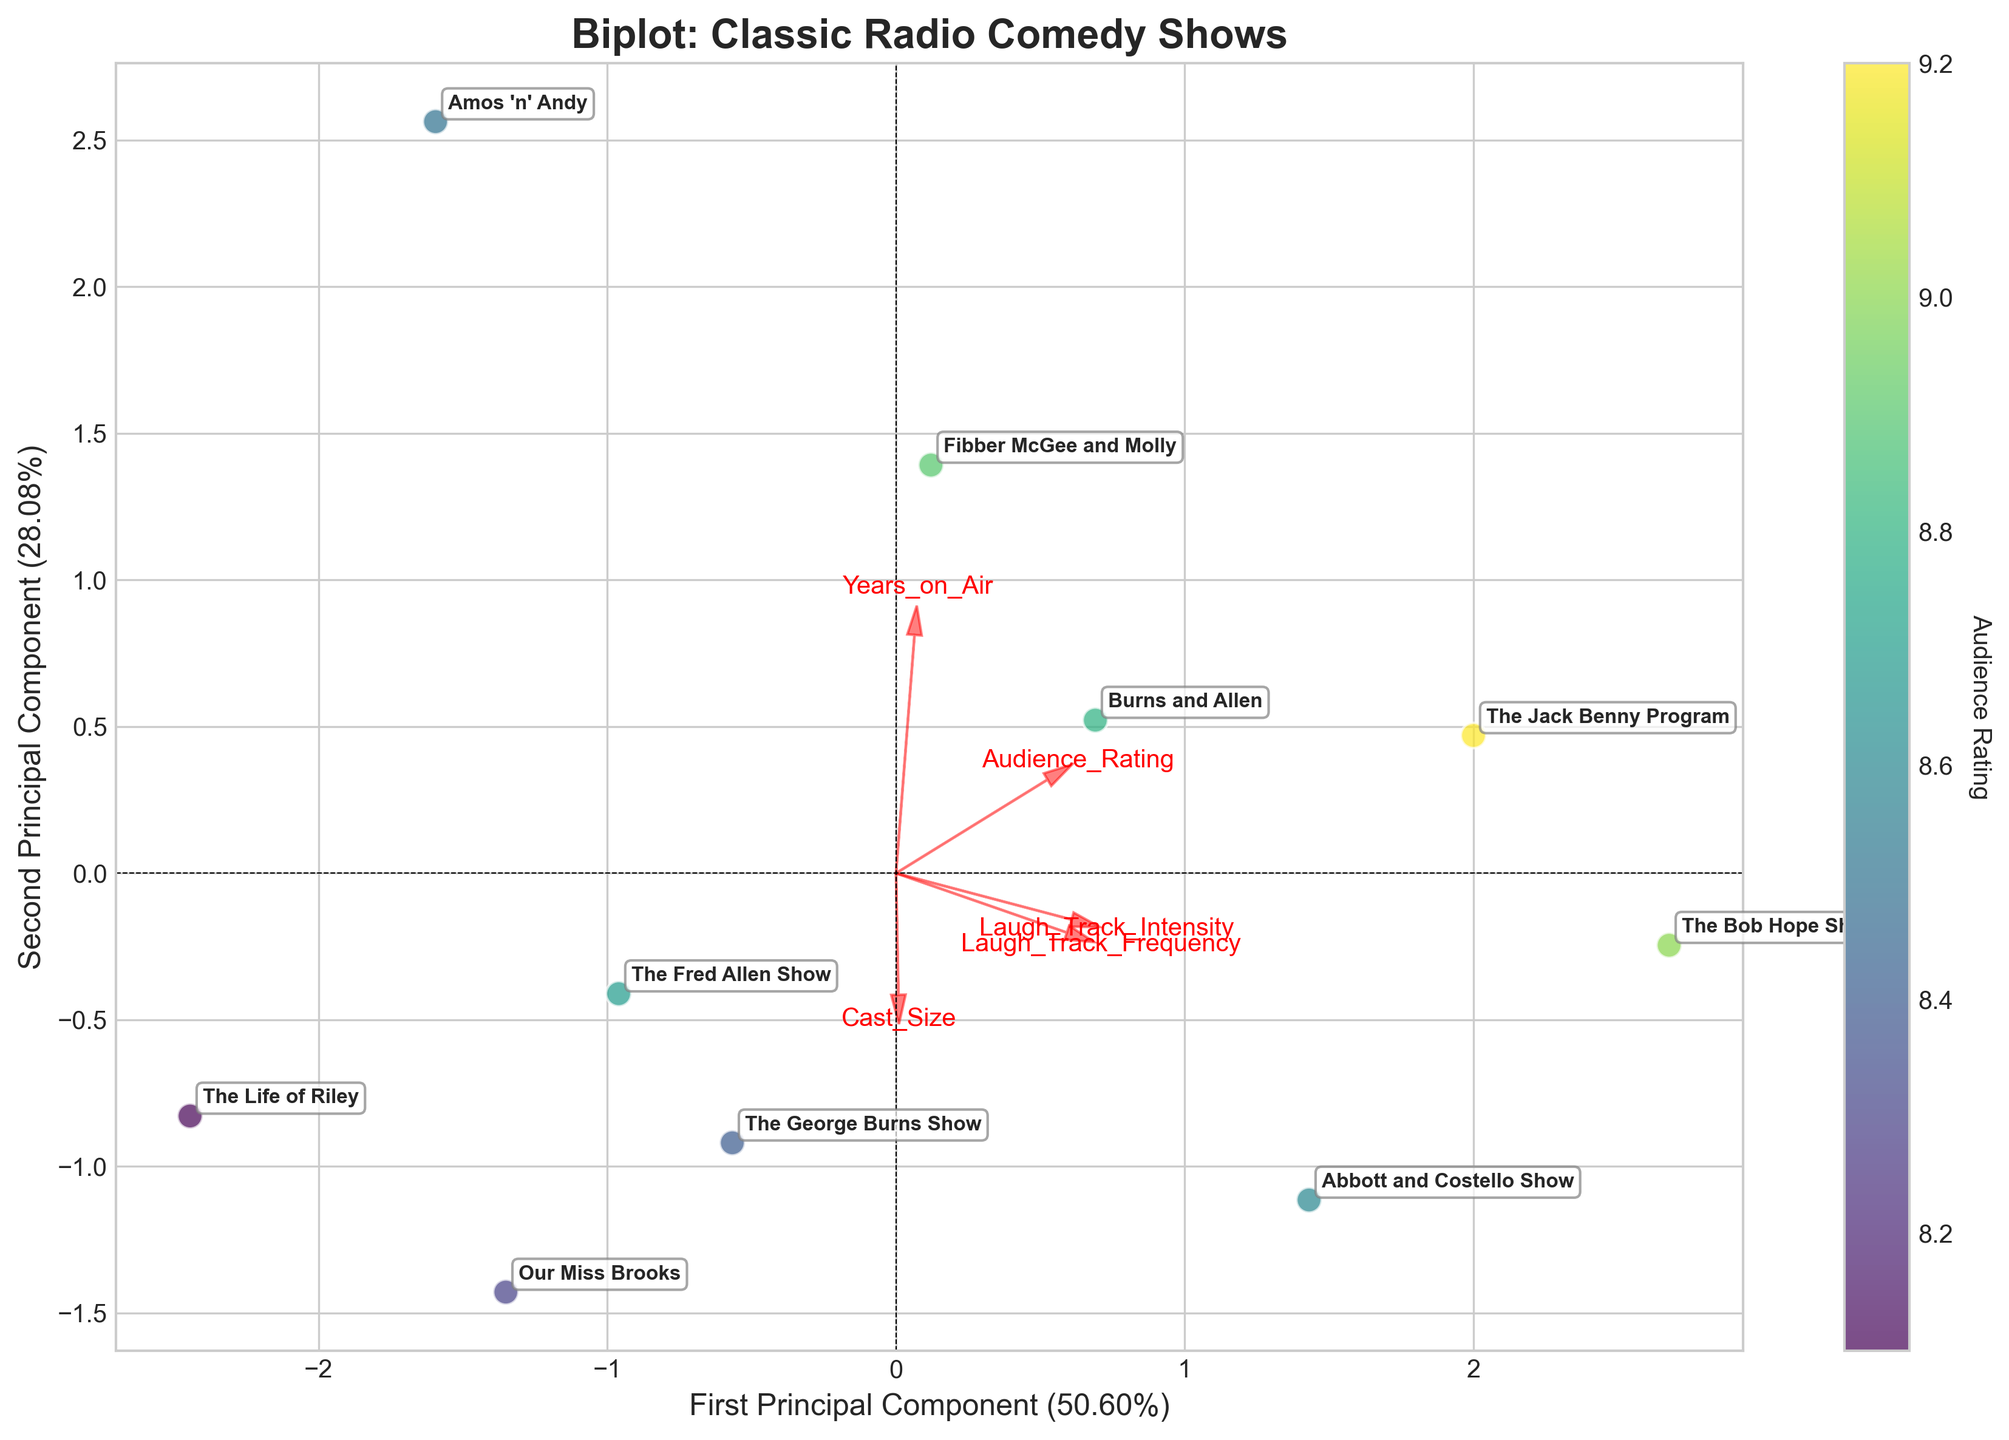What is the title of the plot? The title of the plot is usually displayed at the top of the graph. In this case, it reads "Biplot: Classic Radio Comedy Shows".
Answer: Biplot: Classic Radio Comedy Shows How many principal components are shown on the axes? The labels of the axes mention the number of principal components. The x-axis is labeled "First Principal Component" and the y-axis is labeled "Second Principal Component", indicating there are two principal components presented.
Answer: Two Which show has the highest Audience Rating? The points are colored according to the Audience Rating, with higher ratings shown in different shades. The label "The Jack Benny Program" is positioned at a point with the highest color intensity on the colorbar.
Answer: The Jack Benny Program Which feature has the longest vector, indicating it contributes most to the variance? The lengths of the vectors are depicted by the red arrows. The longest vector usually indicates the most significant feature, which appears to be "Laugh_Track_Frequency" pointed towards the farthest distance.
Answer: Laugh_Track_Frequency Comparing "The Bob Hope Show" and "The Life of Riley," which has a higher Laugh Track Intensity? The biplot shows vectors for features overlapped on the scatter. "The Bob Hope Show" is closer to the vector for Laugh_Track_Intensity compared to "The Life of Riley."
Answer: The Bob Hope Show Which principal component explains more variance and how much? The explained variance is shown in the axis labels. The x-axis indicates "First Principal Component (xx%)" and the y-axis labels "Second Principal Component (yy%)", where xx and yy are the percentages.
Answer: First Principal Component How does "Fibber McGee and Molly" compare with "Burns and Allen" in terms of Years on Air? Look at the projection of points for these shows on the vector corresponding to "Years_on_Air". "Fibber McGee and Molly" is closer to the positive end of this vector compared to "Burns and Allen".
Answer: Fibber McGee and Molly Where is the reference point for the vectors, and what does it represent? The reference point for all vectors is the origin (0,0), indicating the mean position of the standardized data.
Answer: The origin Name two shows with similar positioning in terms of principal components. Look for shows whose labels are closest to each other in the scatter plot. "Fibber McGee and Molly" and "Burns and Allen" are positioned very close to each other.
Answer: Fibber McGee and Molly, Burns and Allen 